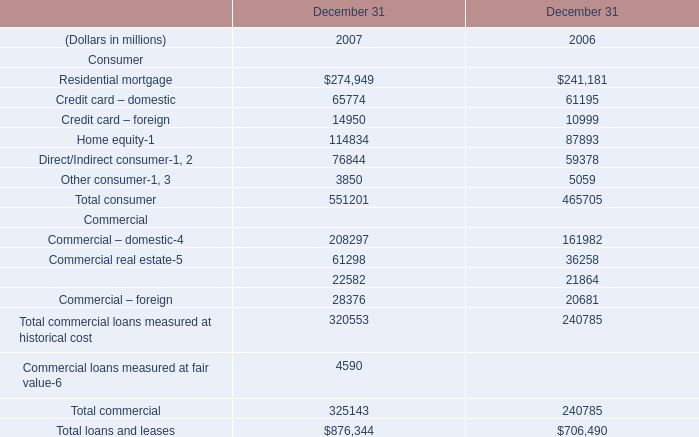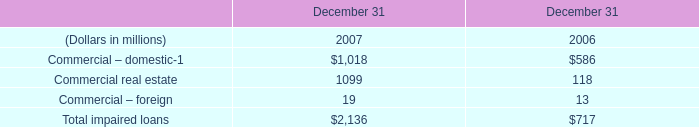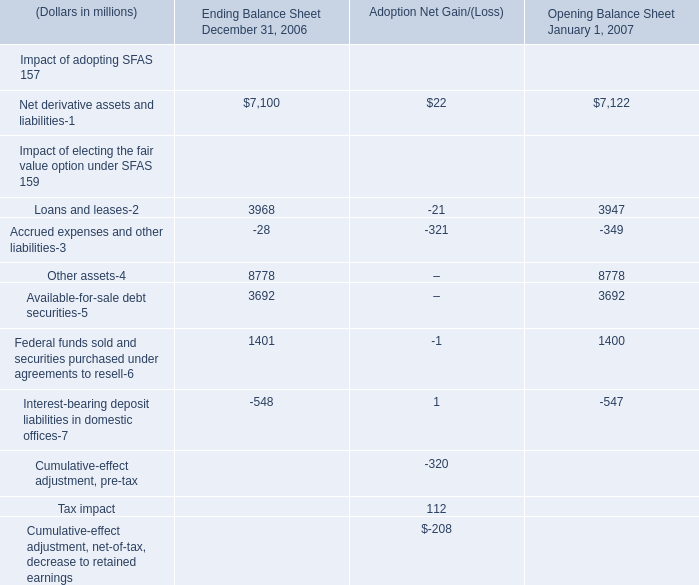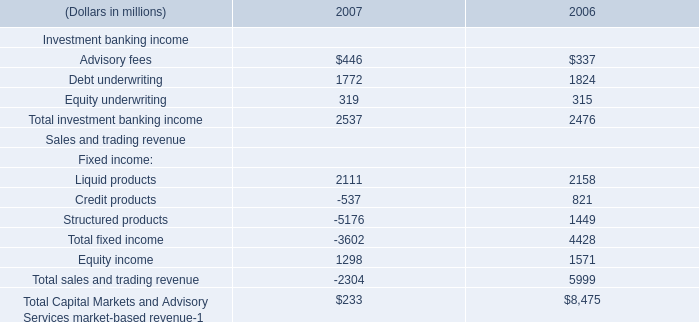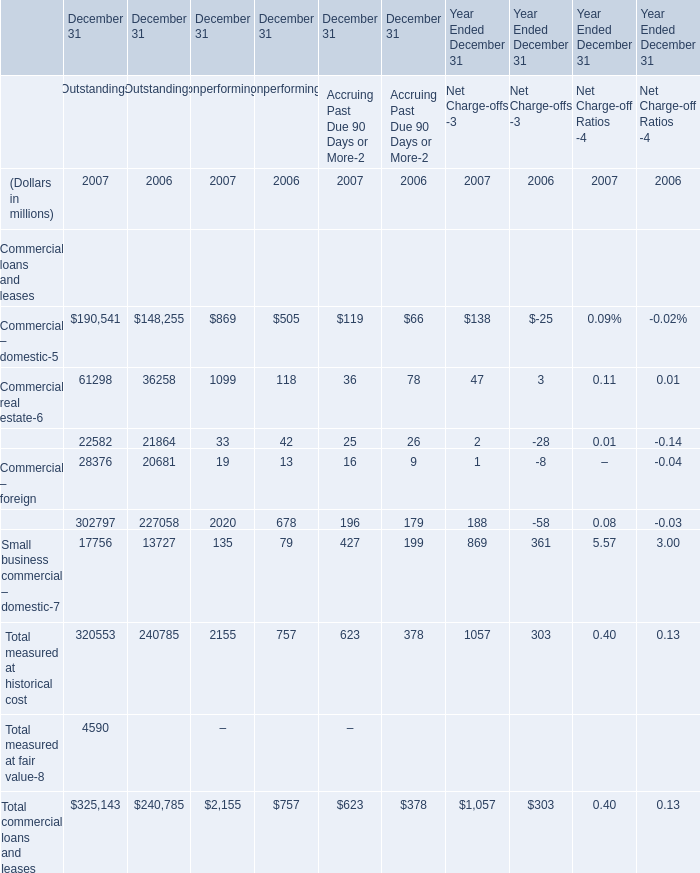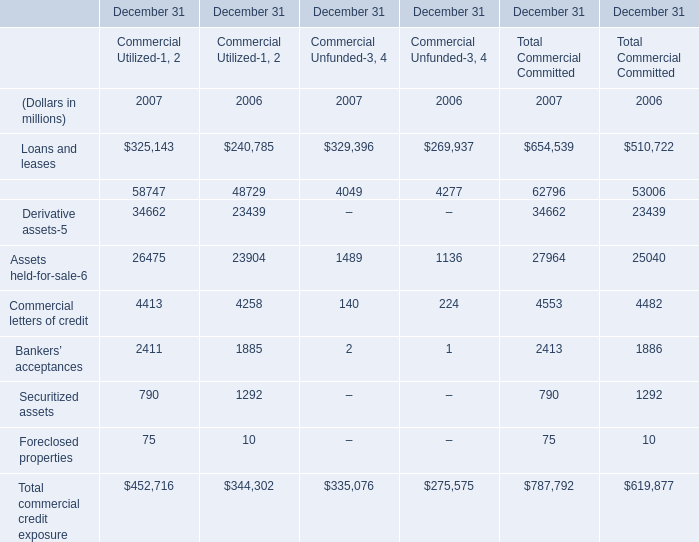What was the average of the Commercial – domestic in the years where Commercial lease financing is positive? (in million) 
Computations: ((((190541 + 869) + 119) + 138) / 4)
Answer: 47916.75. 